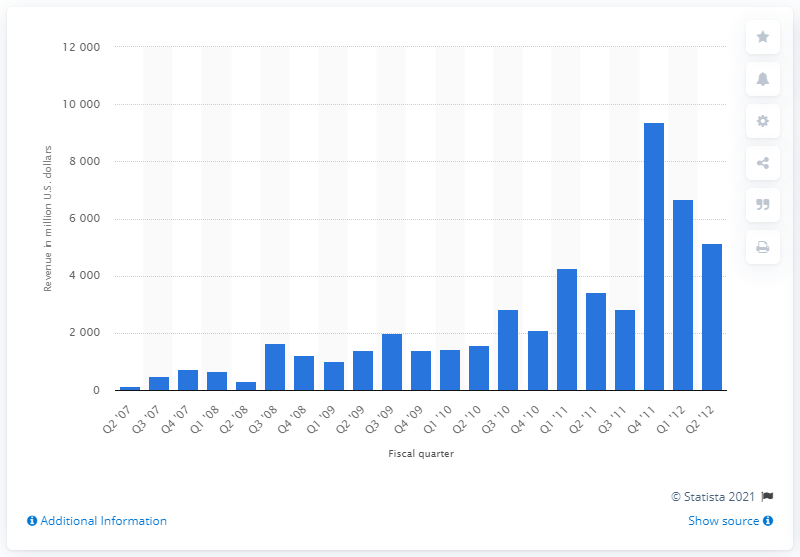Specify some key components in this picture. In the first quarter of 2008, Apple generated 671 million dollars by selling iPhones in the US. 